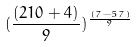<formula> <loc_0><loc_0><loc_500><loc_500>( \frac { ( 2 1 0 + 4 ) } { 9 } ) ^ { \frac { ( 7 - 5 7 ) } { 9 } }</formula> 